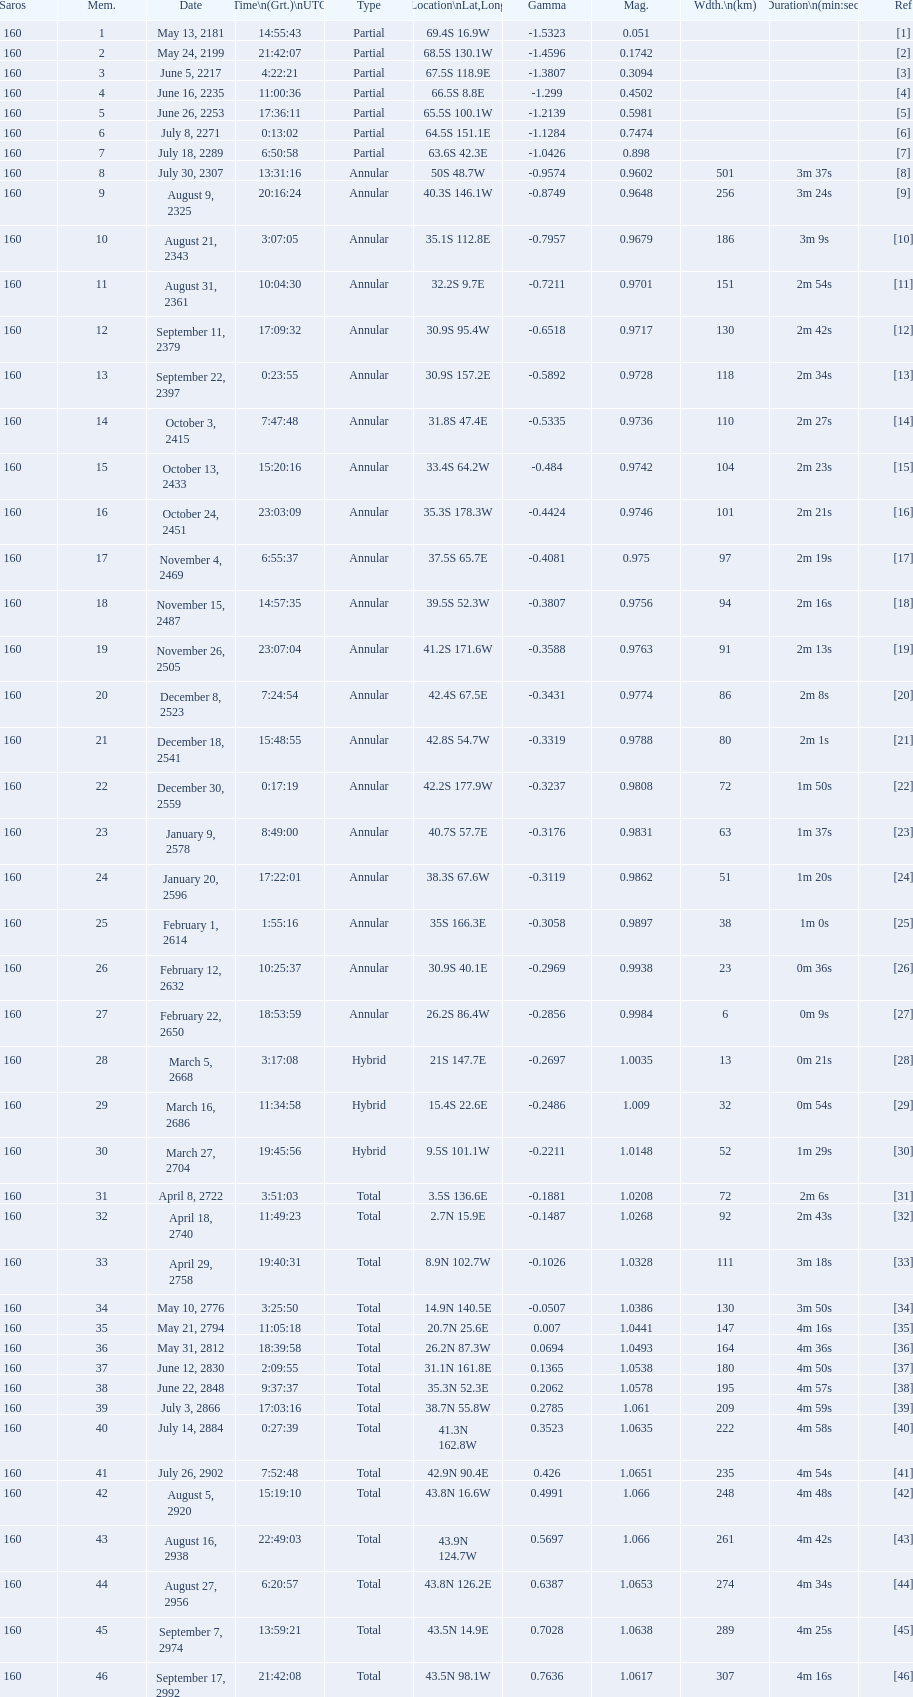When will the next solar saros be after the may 24, 2199 solar saros occurs? June 5, 2217. Give me the full table as a dictionary. {'header': ['Saros', 'Mem.', 'Date', 'Time\\n(Grt.)\\nUTC', 'Type', 'Location\\nLat,Long', 'Gamma', 'Mag.', 'Wdth.\\n(km)', 'Duration\\n(min:sec)', 'Ref'], 'rows': [['160', '1', 'May 13, 2181', '14:55:43', 'Partial', '69.4S 16.9W', '-1.5323', '0.051', '', '', '[1]'], ['160', '2', 'May 24, 2199', '21:42:07', 'Partial', '68.5S 130.1W', '-1.4596', '0.1742', '', '', '[2]'], ['160', '3', 'June 5, 2217', '4:22:21', 'Partial', '67.5S 118.9E', '-1.3807', '0.3094', '', '', '[3]'], ['160', '4', 'June 16, 2235', '11:00:36', 'Partial', '66.5S 8.8E', '-1.299', '0.4502', '', '', '[4]'], ['160', '5', 'June 26, 2253', '17:36:11', 'Partial', '65.5S 100.1W', '-1.2139', '0.5981', '', '', '[5]'], ['160', '6', 'July 8, 2271', '0:13:02', 'Partial', '64.5S 151.1E', '-1.1284', '0.7474', '', '', '[6]'], ['160', '7', 'July 18, 2289', '6:50:58', 'Partial', '63.6S 42.3E', '-1.0426', '0.898', '', '', '[7]'], ['160', '8', 'July 30, 2307', '13:31:16', 'Annular', '50S 48.7W', '-0.9574', '0.9602', '501', '3m 37s', '[8]'], ['160', '9', 'August 9, 2325', '20:16:24', 'Annular', '40.3S 146.1W', '-0.8749', '0.9648', '256', '3m 24s', '[9]'], ['160', '10', 'August 21, 2343', '3:07:05', 'Annular', '35.1S 112.8E', '-0.7957', '0.9679', '186', '3m 9s', '[10]'], ['160', '11', 'August 31, 2361', '10:04:30', 'Annular', '32.2S 9.7E', '-0.7211', '0.9701', '151', '2m 54s', '[11]'], ['160', '12', 'September 11, 2379', '17:09:32', 'Annular', '30.9S 95.4W', '-0.6518', '0.9717', '130', '2m 42s', '[12]'], ['160', '13', 'September 22, 2397', '0:23:55', 'Annular', '30.9S 157.2E', '-0.5892', '0.9728', '118', '2m 34s', '[13]'], ['160', '14', 'October 3, 2415', '7:47:48', 'Annular', '31.8S 47.4E', '-0.5335', '0.9736', '110', '2m 27s', '[14]'], ['160', '15', 'October 13, 2433', '15:20:16', 'Annular', '33.4S 64.2W', '-0.484', '0.9742', '104', '2m 23s', '[15]'], ['160', '16', 'October 24, 2451', '23:03:09', 'Annular', '35.3S 178.3W', '-0.4424', '0.9746', '101', '2m 21s', '[16]'], ['160', '17', 'November 4, 2469', '6:55:37', 'Annular', '37.5S 65.7E', '-0.4081', '0.975', '97', '2m 19s', '[17]'], ['160', '18', 'November 15, 2487', '14:57:35', 'Annular', '39.5S 52.3W', '-0.3807', '0.9756', '94', '2m 16s', '[18]'], ['160', '19', 'November 26, 2505', '23:07:04', 'Annular', '41.2S 171.6W', '-0.3588', '0.9763', '91', '2m 13s', '[19]'], ['160', '20', 'December 8, 2523', '7:24:54', 'Annular', '42.4S 67.5E', '-0.3431', '0.9774', '86', '2m 8s', '[20]'], ['160', '21', 'December 18, 2541', '15:48:55', 'Annular', '42.8S 54.7W', '-0.3319', '0.9788', '80', '2m 1s', '[21]'], ['160', '22', 'December 30, 2559', '0:17:19', 'Annular', '42.2S 177.9W', '-0.3237', '0.9808', '72', '1m 50s', '[22]'], ['160', '23', 'January 9, 2578', '8:49:00', 'Annular', '40.7S 57.7E', '-0.3176', '0.9831', '63', '1m 37s', '[23]'], ['160', '24', 'January 20, 2596', '17:22:01', 'Annular', '38.3S 67.6W', '-0.3119', '0.9862', '51', '1m 20s', '[24]'], ['160', '25', 'February 1, 2614', '1:55:16', 'Annular', '35S 166.3E', '-0.3058', '0.9897', '38', '1m 0s', '[25]'], ['160', '26', 'February 12, 2632', '10:25:37', 'Annular', '30.9S 40.1E', '-0.2969', '0.9938', '23', '0m 36s', '[26]'], ['160', '27', 'February 22, 2650', '18:53:59', 'Annular', '26.2S 86.4W', '-0.2856', '0.9984', '6', '0m 9s', '[27]'], ['160', '28', 'March 5, 2668', '3:17:08', 'Hybrid', '21S 147.7E', '-0.2697', '1.0035', '13', '0m 21s', '[28]'], ['160', '29', 'March 16, 2686', '11:34:58', 'Hybrid', '15.4S 22.6E', '-0.2486', '1.009', '32', '0m 54s', '[29]'], ['160', '30', 'March 27, 2704', '19:45:56', 'Hybrid', '9.5S 101.1W', '-0.2211', '1.0148', '52', '1m 29s', '[30]'], ['160', '31', 'April 8, 2722', '3:51:03', 'Total', '3.5S 136.6E', '-0.1881', '1.0208', '72', '2m 6s', '[31]'], ['160', '32', 'April 18, 2740', '11:49:23', 'Total', '2.7N 15.9E', '-0.1487', '1.0268', '92', '2m 43s', '[32]'], ['160', '33', 'April 29, 2758', '19:40:31', 'Total', '8.9N 102.7W', '-0.1026', '1.0328', '111', '3m 18s', '[33]'], ['160', '34', 'May 10, 2776', '3:25:50', 'Total', '14.9N 140.5E', '-0.0507', '1.0386', '130', '3m 50s', '[34]'], ['160', '35', 'May 21, 2794', '11:05:18', 'Total', '20.7N 25.6E', '0.007', '1.0441', '147', '4m 16s', '[35]'], ['160', '36', 'May 31, 2812', '18:39:58', 'Total', '26.2N 87.3W', '0.0694', '1.0493', '164', '4m 36s', '[36]'], ['160', '37', 'June 12, 2830', '2:09:55', 'Total', '31.1N 161.8E', '0.1365', '1.0538', '180', '4m 50s', '[37]'], ['160', '38', 'June 22, 2848', '9:37:37', 'Total', '35.3N 52.3E', '0.2062', '1.0578', '195', '4m 57s', '[38]'], ['160', '39', 'July 3, 2866', '17:03:16', 'Total', '38.7N 55.8W', '0.2785', '1.061', '209', '4m 59s', '[39]'], ['160', '40', 'July 14, 2884', '0:27:39', 'Total', '41.3N 162.8W', '0.3523', '1.0635', '222', '4m 58s', '[40]'], ['160', '41', 'July 26, 2902', '7:52:48', 'Total', '42.9N 90.4E', '0.426', '1.0651', '235', '4m 54s', '[41]'], ['160', '42', 'August 5, 2920', '15:19:10', 'Total', '43.8N 16.6W', '0.4991', '1.066', '248', '4m 48s', '[42]'], ['160', '43', 'August 16, 2938', '22:49:03', 'Total', '43.9N 124.7W', '0.5697', '1.066', '261', '4m 42s', '[43]'], ['160', '44', 'August 27, 2956', '6:20:57', 'Total', '43.8N 126.2E', '0.6387', '1.0653', '274', '4m 34s', '[44]'], ['160', '45', 'September 7, 2974', '13:59:21', 'Total', '43.5N 14.9E', '0.7028', '1.0638', '289', '4m 25s', '[45]'], ['160', '46', 'September 17, 2992', '21:42:08', 'Total', '43.5N 98.1W', '0.7636', '1.0617', '307', '4m 16s', '[46]']]} 